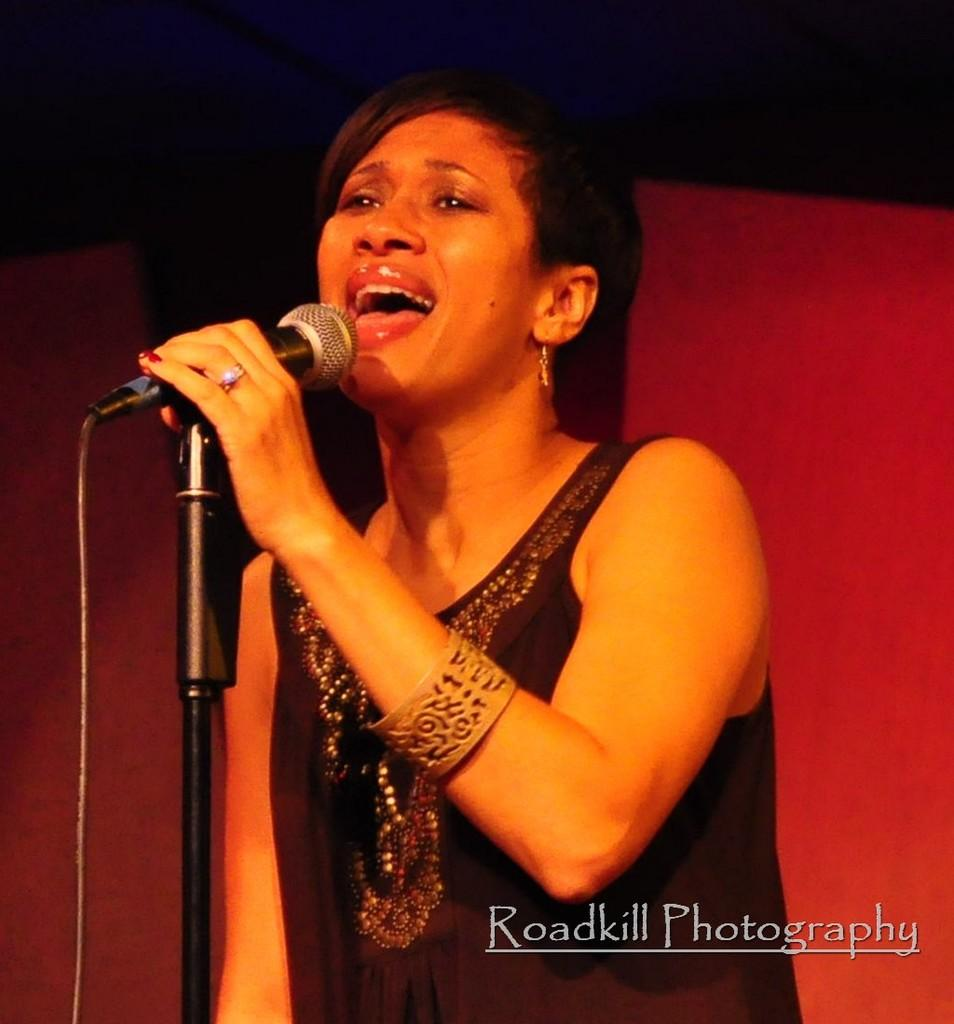Who is the main subject in the image? There is a woman in the image. What is the woman doing in the image? The woman is singing in the image. What object is in front of the woman? There is a microphone in front of the woman. How many ladybugs can be seen on the woman's shoulder in the image? There are no ladybugs present in the image. What type of stew is being prepared in the background of the image? There is no stew or any cooking activity visible in the image. 